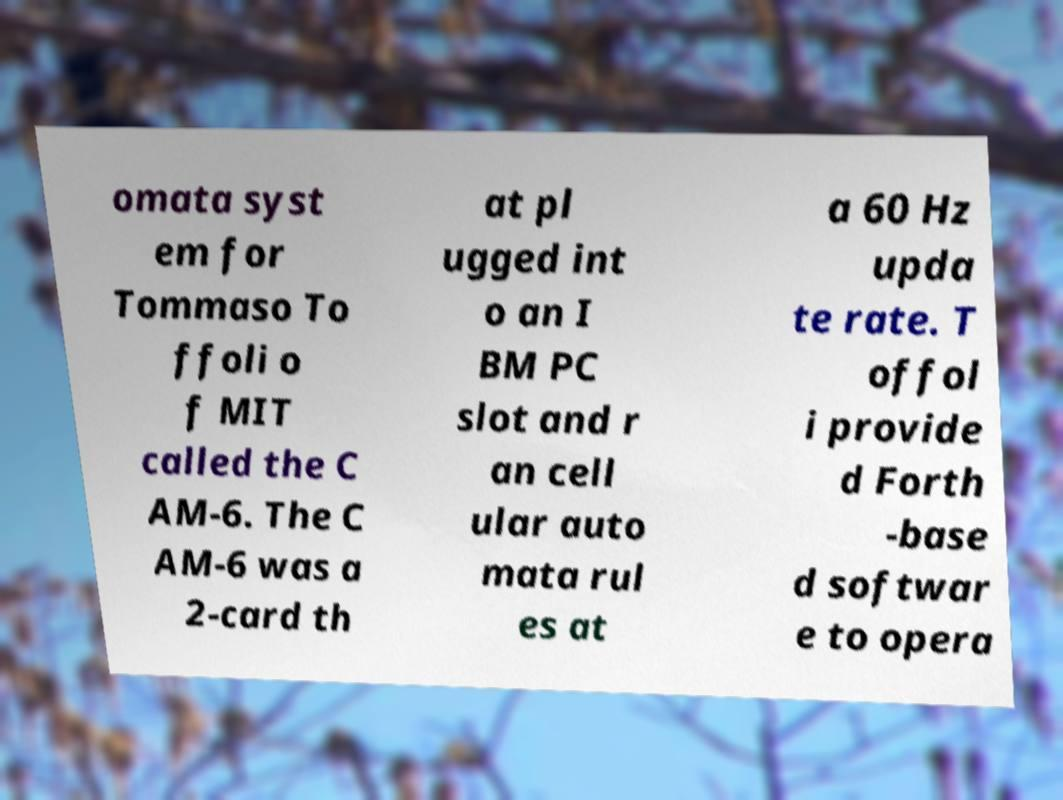What messages or text are displayed in this image? I need them in a readable, typed format. omata syst em for Tommaso To ffoli o f MIT called the C AM-6. The C AM-6 was a 2-card th at pl ugged int o an I BM PC slot and r an cell ular auto mata rul es at a 60 Hz upda te rate. T offol i provide d Forth -base d softwar e to opera 